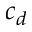Convert formula to latex. <formula><loc_0><loc_0><loc_500><loc_500>c _ { d }</formula> 